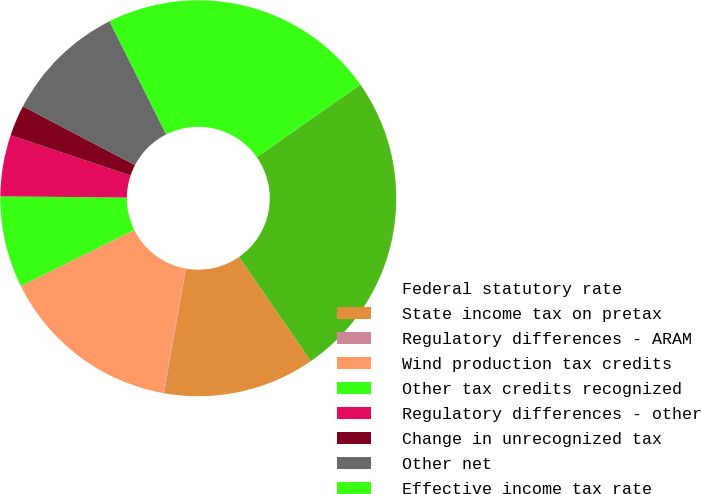Convert chart. <chart><loc_0><loc_0><loc_500><loc_500><pie_chart><fcel>Federal statutory rate<fcel>State income tax on pretax<fcel>Regulatory differences - ARAM<fcel>Wind production tax credits<fcel>Other tax credits recognized<fcel>Regulatory differences - other<fcel>Change in unrecognized tax<fcel>Other net<fcel>Effective income tax rate<nl><fcel>25.12%<fcel>12.39%<fcel>0.07%<fcel>14.85%<fcel>7.46%<fcel>5.0%<fcel>2.53%<fcel>9.92%<fcel>22.66%<nl></chart> 